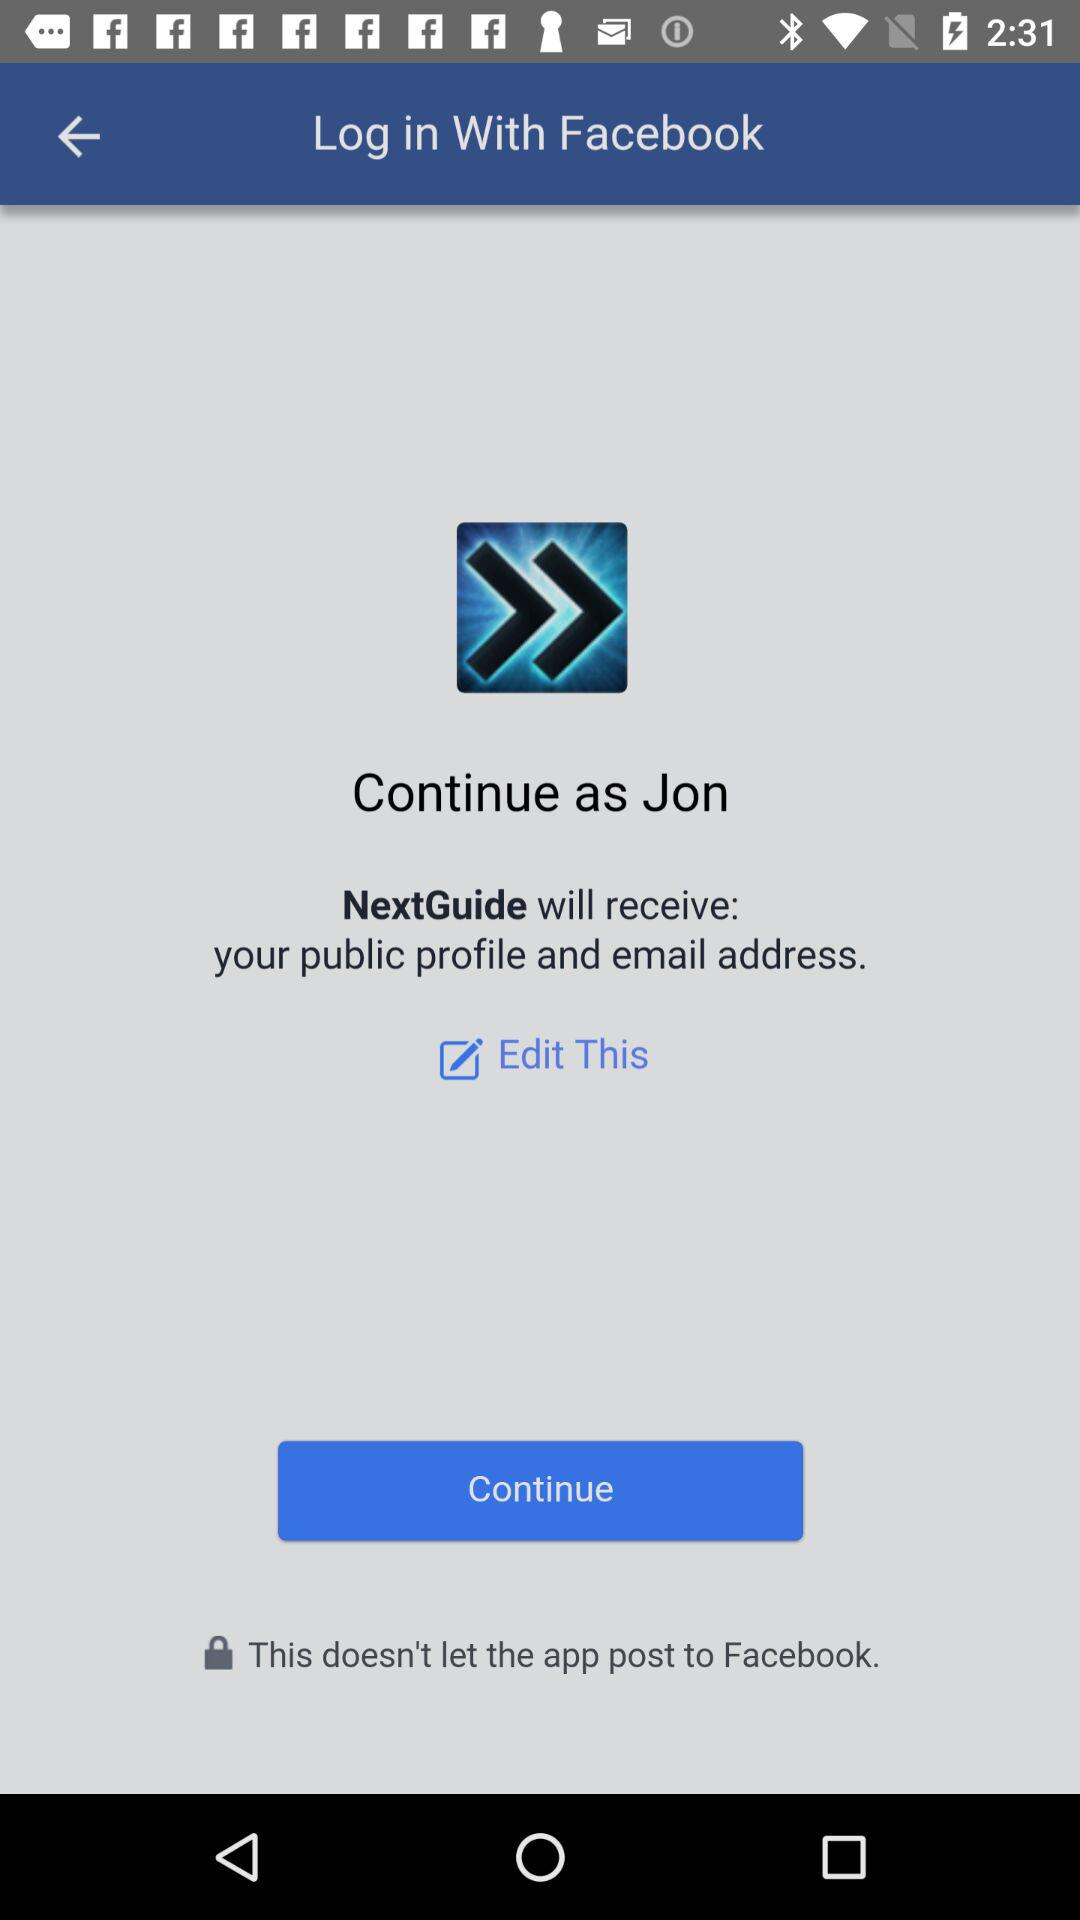What is the application name? The application name is "NextGuide". 